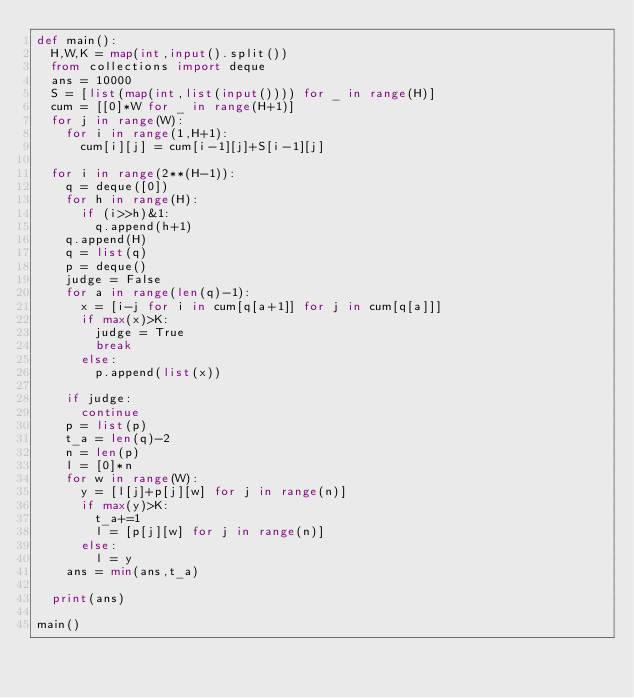<code> <loc_0><loc_0><loc_500><loc_500><_Python_>def main():
  H,W,K = map(int,input().split())
  from collections import deque
  ans = 10000
  S = [list(map(int,list(input()))) for _ in range(H)]
  cum = [[0]*W for _ in range(H+1)]
  for j in range(W):
    for i in range(1,H+1):
      cum[i][j] = cum[i-1][j]+S[i-1][j]

  for i in range(2**(H-1)):
    q = deque([0])
    for h in range(H):
      if (i>>h)&1:
        q.append(h+1)
    q.append(H)
    q = list(q)
    p = deque()
    judge = False
    for a in range(len(q)-1):
      x = [i-j for i in cum[q[a+1]] for j in cum[q[a]]]
      if max(x)>K:
        judge = True
        break
      else:
        p.append(list(x))

    if judge:
      continue
    p = list(p)
    t_a = len(q)-2
    n = len(p)
    l = [0]*n
    for w in range(W):
      y = [l[j]+p[j][w] for j in range(n)]
      if max(y)>K:
        t_a+=1
        l = [p[j][w] for j in range(n)]
      else:
        l = y
    ans = min(ans,t_a)

  print(ans)
  
main()</code> 